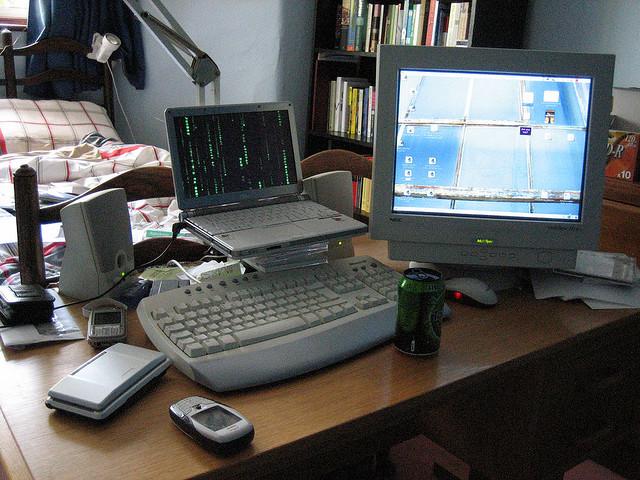What do the symbols on the tablet screen represent?
Write a very short answer. Matrix. How many screens are in the image?
Be succinct. 2. How many cell phones are on the desk?
Short answer required. 2. Why are there two computers?
Short answer required. Work. 